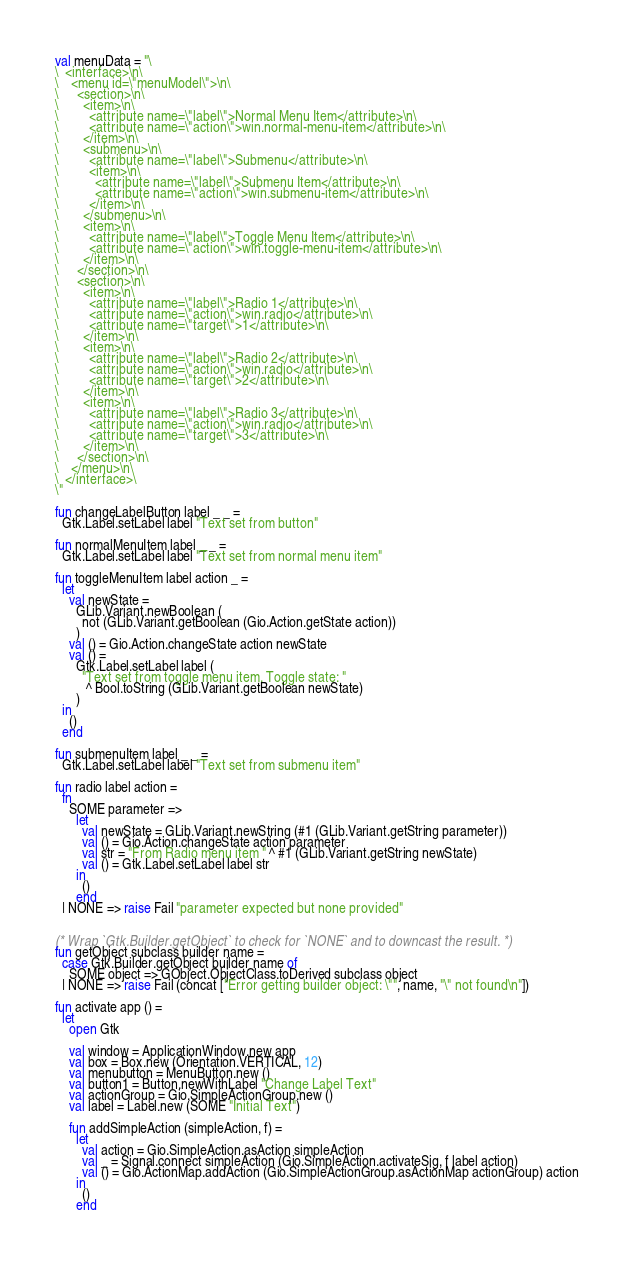Convert code to text. <code><loc_0><loc_0><loc_500><loc_500><_SML_>val menuData = "\
\  <interface>\n\
\    <menu id=\"menuModel\">\n\
\      <section>\n\
\        <item>\n\
\          <attribute name=\"label\">Normal Menu Item</attribute>\n\
\          <attribute name=\"action\">win.normal-menu-item</attribute>\n\
\        </item>\n\
\        <submenu>\n\
\          <attribute name=\"label\">Submenu</attribute>\n\
\          <item>\n\
\            <attribute name=\"label\">Submenu Item</attribute>\n\
\            <attribute name=\"action\">win.submenu-item</attribute>\n\
\          </item>\n\
\        </submenu>\n\
\        <item>\n\
\          <attribute name=\"label\">Toggle Menu Item</attribute>\n\
\          <attribute name=\"action\">win.toggle-menu-item</attribute>\n\
\        </item>\n\
\      </section>\n\
\      <section>\n\
\        <item>\n\
\          <attribute name=\"label\">Radio 1</attribute>\n\
\          <attribute name=\"action\">win.radio</attribute>\n\
\          <attribute name=\"target\">1</attribute>\n\
\        </item>\n\
\        <item>\n\
\          <attribute name=\"label\">Radio 2</attribute>\n\
\          <attribute name=\"action\">win.radio</attribute>\n\
\          <attribute name=\"target\">2</attribute>\n\
\        </item>\n\
\        <item>\n\
\          <attribute name=\"label\">Radio 3</attribute>\n\
\          <attribute name=\"action\">win.radio</attribute>\n\
\          <attribute name=\"target\">3</attribute>\n\
\        </item>\n\
\      </section>\n\
\    </menu>\n\
\  </interface>\
\"

fun changeLabelButton label _ _ =
  Gtk.Label.setLabel label "Text set from button"

fun normalMenuItem label _ _ =
  Gtk.Label.setLabel label "Text set from normal menu item"

fun toggleMenuItem label action _ =
  let
    val newState =
      GLib.Variant.newBoolean (
        not (GLib.Variant.getBoolean (Gio.Action.getState action))
      )
    val () = Gio.Action.changeState action newState
    val () =
      Gtk.Label.setLabel label (
        "Text set from toggle menu item. Toggle state: "
         ^ Bool.toString (GLib.Variant.getBoolean newState)
      )
  in
    ()
  end

fun submenuItem label _ _ =
  Gtk.Label.setLabel label "Text set from submenu item"

fun radio label action =
  fn
    SOME parameter =>
      let
        val newState = GLib.Variant.newString (#1 (GLib.Variant.getString parameter))
        val () = Gio.Action.changeState action parameter
        val str = "From Radio menu item " ^ #1 (GLib.Variant.getString newState)
        val () = Gtk.Label.setLabel label str
      in
        ()
      end
  | NONE => raise Fail "parameter expected but none provided"


(* Wrap `Gtk.Builder.getObject` to check for `NONE` and to downcast the result. *)
fun getObject subclass builder name =
  case Gtk.Builder.getObject builder name of
    SOME object => GObject.ObjectClass.toDerived subclass object
  | NONE => raise Fail (concat ["Error getting builder object: \"", name, "\" not found\n"])

fun activate app () =
  let
    open Gtk

    val window = ApplicationWindow.new app
    val box = Box.new (Orientation.VERTICAL, 12)
    val menubutton = MenuButton.new ()
    val button1 = Button.newWithLabel "Change Label Text"
    val actionGroup = Gio.SimpleActionGroup.new ()
    val label = Label.new (SOME "Initial Text")

    fun addSimpleAction (simpleAction, f) =
      let
        val action = Gio.SimpleAction.asAction simpleAction
        val _ = Signal.connect simpleAction (Gio.SimpleAction.activateSig, f label action)
        val () = Gio.ActionMap.addAction (Gio.SimpleActionGroup.asActionMap actionGroup) action
      in
        ()
      end
</code> 